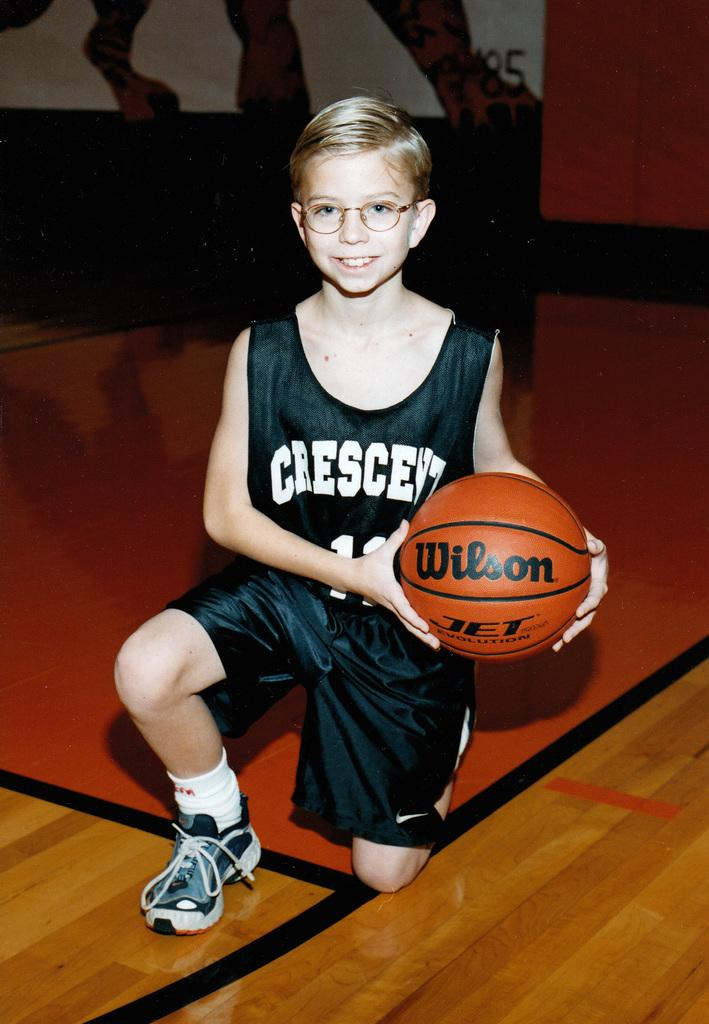What is the main subject of the image? The main subject of the image is a boy. What is the boy holding in the image? The boy is holding a ball. What can be seen in the background behind the boy? There is a banner behind the boy. What type of oven is visible in the image? There is no oven present in the image. What is the boy's state of mind in the image? The image does not provide information about the boy's state of mind. 